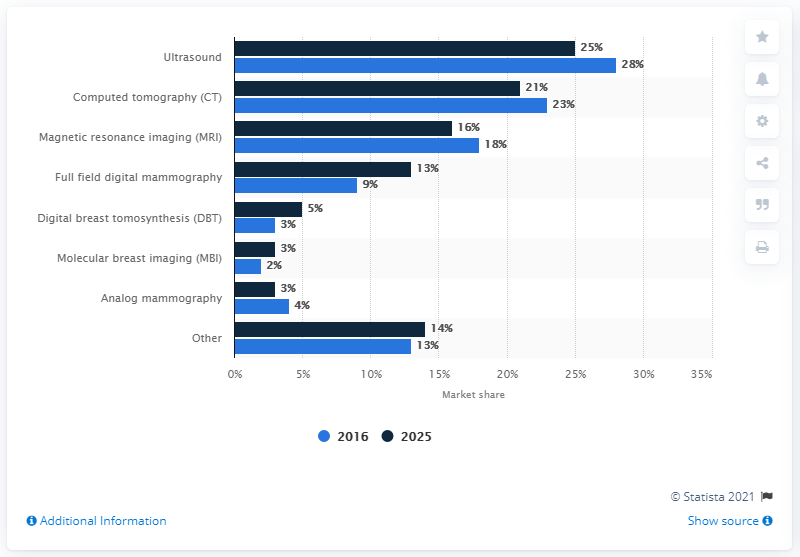List a handful of essential elements in this visual. In 2016, the market share of ultrasound was 25%. According to the computed tomography's share in the global cancer imaging systems market, it was found to be approximately 23%. The combined market share of computed tomography (CT), magnetic resonance imaging (MRI), and ultrasound in 2016 was 69%. The forecast for the global cancer imaging systems market in 2025 is expected to be significant. 